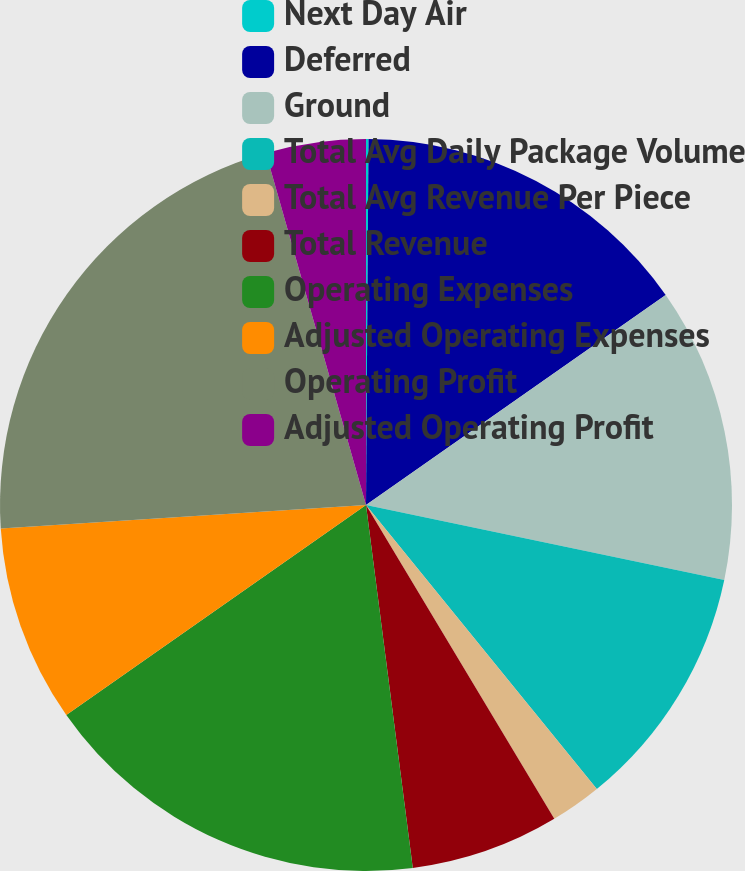Convert chart. <chart><loc_0><loc_0><loc_500><loc_500><pie_chart><fcel>Next Day Air<fcel>Deferred<fcel>Ground<fcel>Total Avg Daily Package Volume<fcel>Total Avg Revenue Per Piece<fcel>Total Revenue<fcel>Operating Expenses<fcel>Adjusted Operating Expenses<fcel>Operating Profit<fcel>Adjusted Operating Profit<nl><fcel>0.11%<fcel>15.16%<fcel>13.01%<fcel>10.86%<fcel>2.26%<fcel>6.56%<fcel>17.31%<fcel>8.71%<fcel>21.61%<fcel>4.41%<nl></chart> 